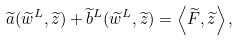<formula> <loc_0><loc_0><loc_500><loc_500>\widetilde { a } ( \widetilde { w } ^ { L } , \widetilde { z } ) + \widetilde { b } ^ { L } ( \widetilde { w } ^ { L } , \widetilde { z } ) = \left < \widetilde { F } , \widetilde { z } \right > ,</formula> 